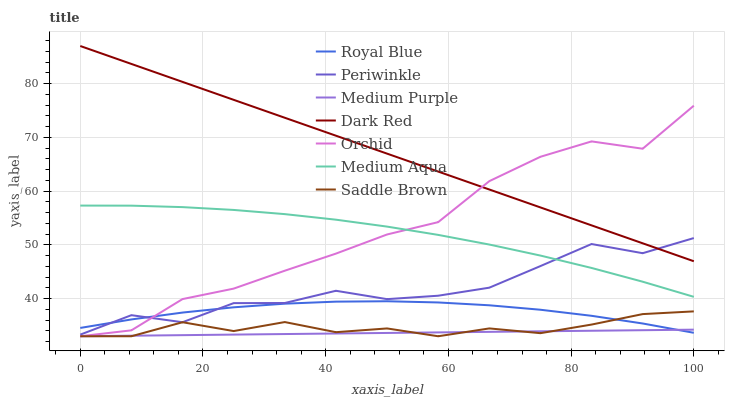Does Medium Purple have the minimum area under the curve?
Answer yes or no. Yes. Does Dark Red have the maximum area under the curve?
Answer yes or no. Yes. Does Royal Blue have the minimum area under the curve?
Answer yes or no. No. Does Royal Blue have the maximum area under the curve?
Answer yes or no. No. Is Medium Purple the smoothest?
Answer yes or no. Yes. Is Orchid the roughest?
Answer yes or no. Yes. Is Royal Blue the smoothest?
Answer yes or no. No. Is Royal Blue the roughest?
Answer yes or no. No. Does Medium Purple have the lowest value?
Answer yes or no. Yes. Does Royal Blue have the lowest value?
Answer yes or no. No. Does Dark Red have the highest value?
Answer yes or no. Yes. Does Royal Blue have the highest value?
Answer yes or no. No. Is Medium Purple less than Periwinkle?
Answer yes or no. Yes. Is Periwinkle greater than Saddle Brown?
Answer yes or no. Yes. Does Orchid intersect Medium Aqua?
Answer yes or no. Yes. Is Orchid less than Medium Aqua?
Answer yes or no. No. Is Orchid greater than Medium Aqua?
Answer yes or no. No. Does Medium Purple intersect Periwinkle?
Answer yes or no. No. 